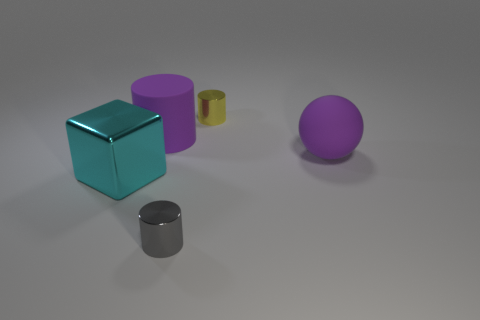There is a gray thing that is the same size as the yellow metallic cylinder; what material is it?
Offer a terse response. Metal. What number of other things are there of the same material as the purple cylinder
Offer a very short reply. 1. Is the number of large purple matte objects the same as the number of big blocks?
Your answer should be very brief. No. What color is the thing that is in front of the matte sphere and to the right of the big metal object?
Make the answer very short. Gray. What number of objects are either objects to the left of the small gray thing or tiny blue matte cylinders?
Give a very brief answer. 2. What number of other things are there of the same color as the large shiny cube?
Your response must be concise. 0. Are there an equal number of tiny gray shiny cylinders behind the small gray metallic cylinder and tiny yellow metal things?
Keep it short and to the point. No. How many tiny cylinders are in front of the big purple matte thing left of the small cylinder in front of the purple matte cylinder?
Offer a terse response. 1. Is there anything else that is the same size as the purple rubber ball?
Ensure brevity in your answer.  Yes. There is a gray metal cylinder; is its size the same as the shiny thing that is behind the big shiny cube?
Give a very brief answer. Yes. 